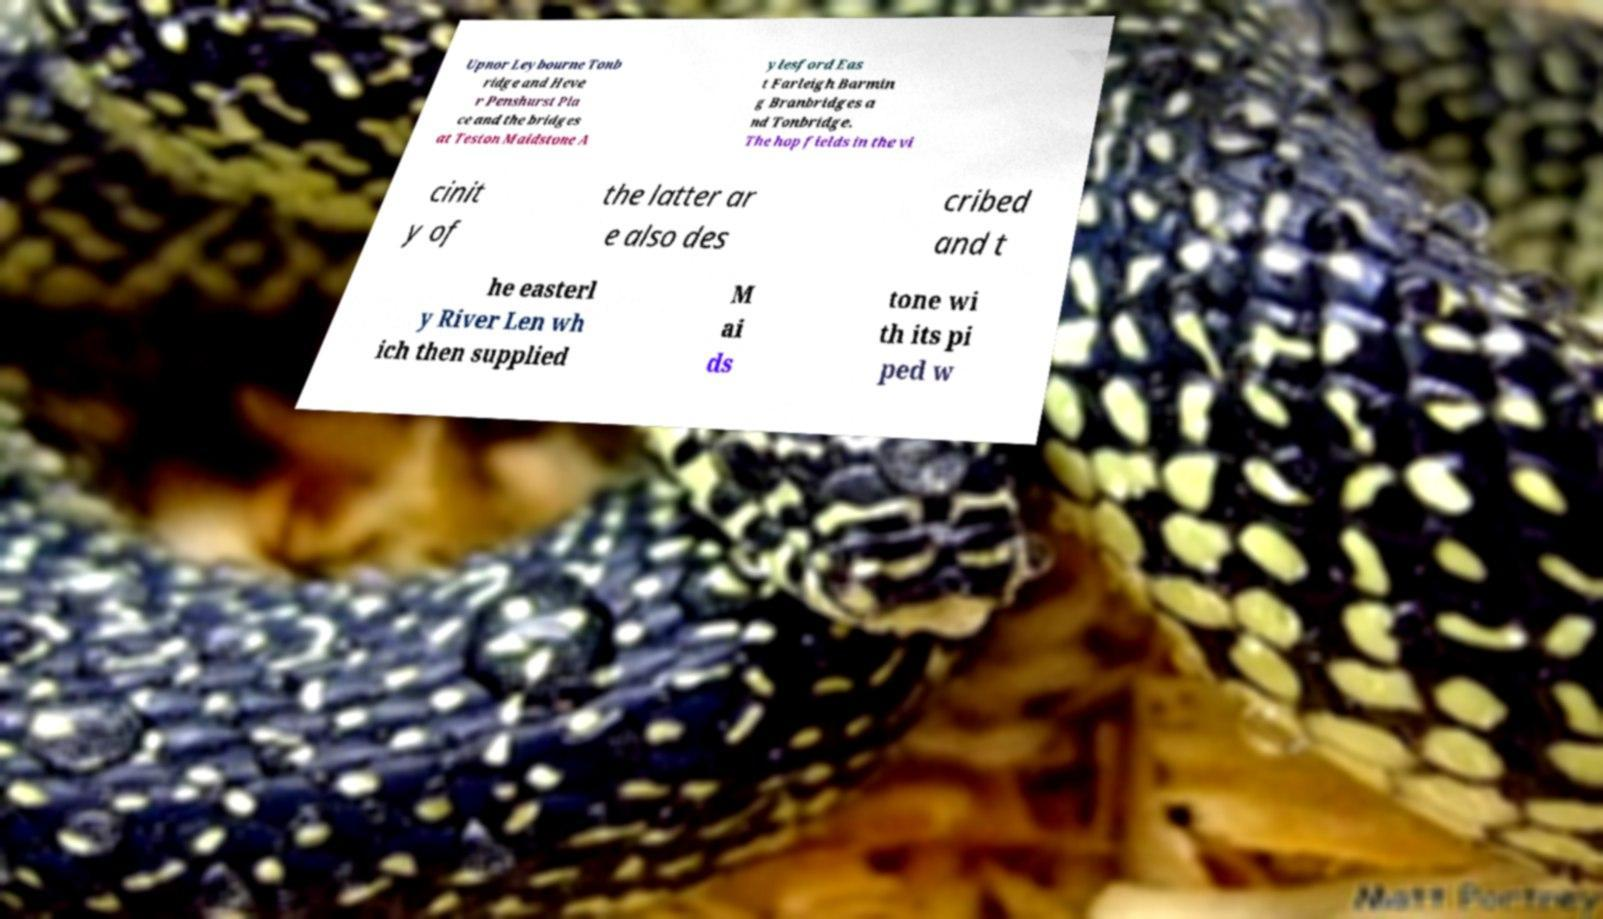Could you extract and type out the text from this image? Upnor Leybourne Tonb ridge and Heve r Penshurst Pla ce and the bridges at Teston Maidstone A ylesford Eas t Farleigh Barmin g Branbridges a nd Tonbridge. The hop fields in the vi cinit y of the latter ar e also des cribed and t he easterl y River Len wh ich then supplied M ai ds tone wi th its pi ped w 